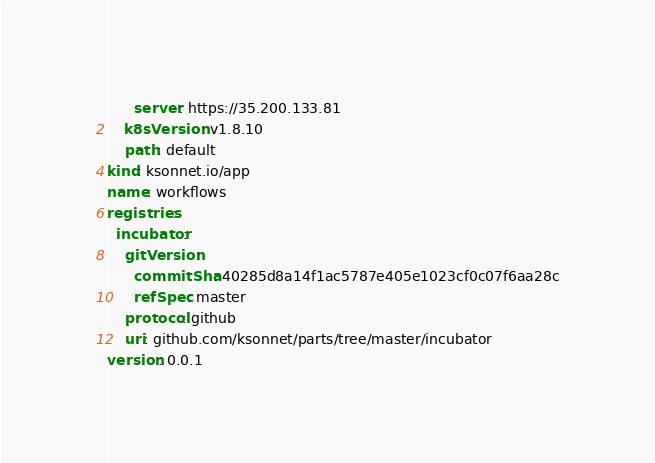<code> <loc_0><loc_0><loc_500><loc_500><_YAML_>      server: https://35.200.133.81
    k8sVersion: v1.8.10
    path: default
kind: ksonnet.io/app
name: workflows
registries:
  incubator:
    gitVersion:
      commitSha: 40285d8a14f1ac5787e405e1023cf0c07f6aa28c
      refSpec: master
    protocol: github
    uri: github.com/ksonnet/parts/tree/master/incubator
version: 0.0.1
</code> 